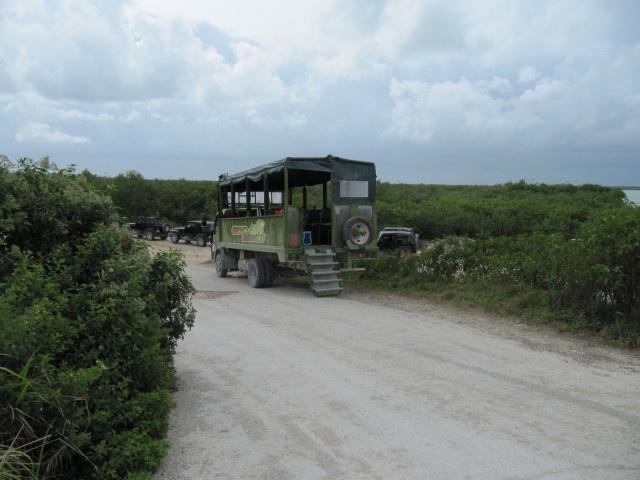What does the truck have a spare of on the back?
Choose the right answer from the provided options to respond to the question.
Options: Gas tank, tire, motor, seat. Tire. 